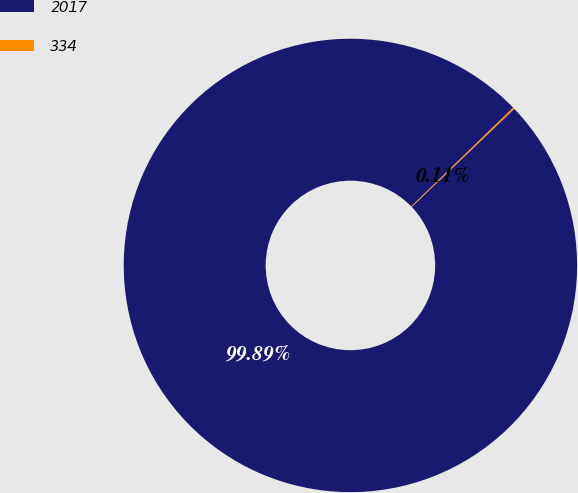Convert chart. <chart><loc_0><loc_0><loc_500><loc_500><pie_chart><fcel>2017<fcel>334<nl><fcel>99.89%<fcel>0.11%<nl></chart> 